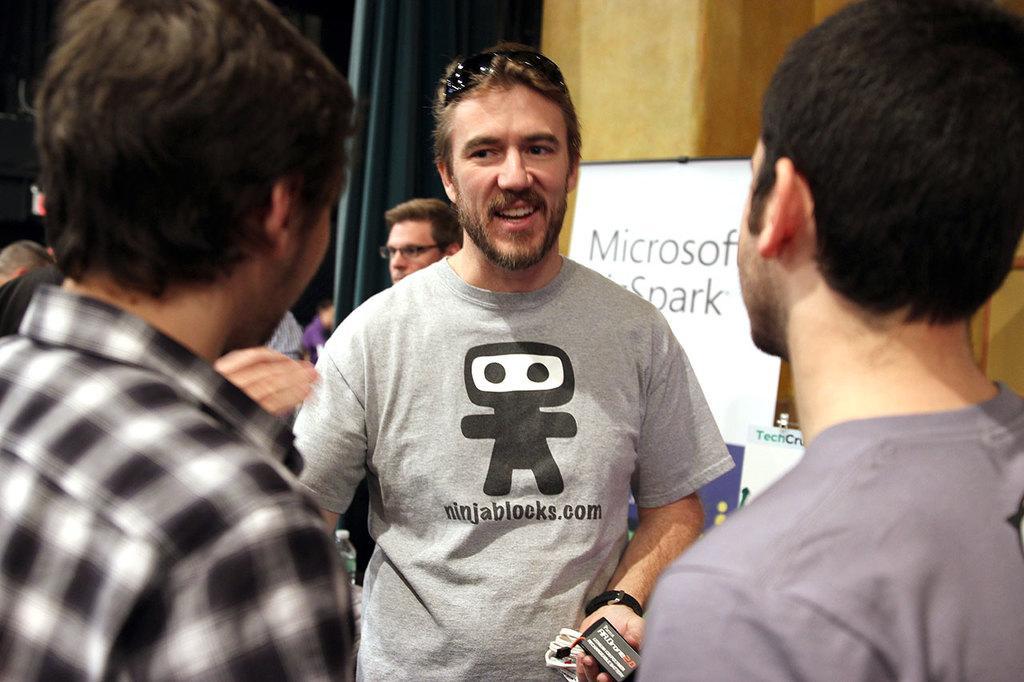In one or two sentences, can you explain what this image depicts? In the image in the center, we can see a few people are standing and the middle person is holding some object and he is smiling. In the background there is a wall, banner and a few other objects. 